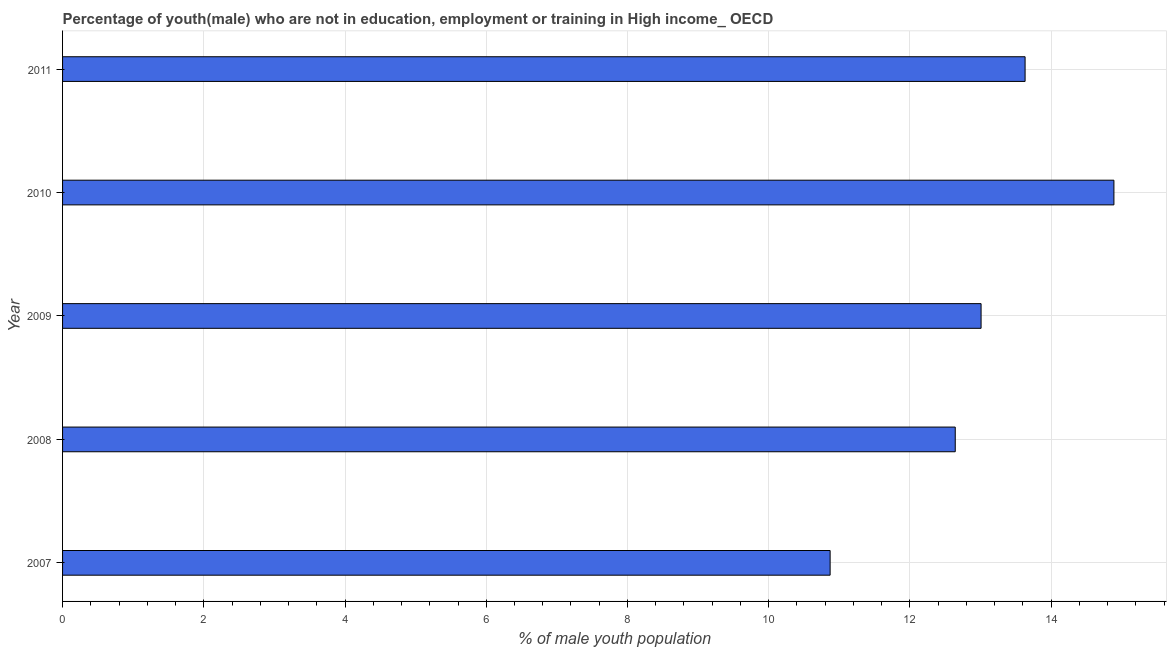Does the graph contain any zero values?
Give a very brief answer. No. What is the title of the graph?
Offer a terse response. Percentage of youth(male) who are not in education, employment or training in High income_ OECD. What is the label or title of the X-axis?
Keep it short and to the point. % of male youth population. What is the label or title of the Y-axis?
Your answer should be very brief. Year. What is the unemployed male youth population in 2008?
Make the answer very short. 12.64. Across all years, what is the maximum unemployed male youth population?
Your answer should be compact. 14.89. Across all years, what is the minimum unemployed male youth population?
Provide a succinct answer. 10.87. In which year was the unemployed male youth population minimum?
Provide a succinct answer. 2007. What is the sum of the unemployed male youth population?
Your answer should be very brief. 65.04. What is the difference between the unemployed male youth population in 2009 and 2011?
Offer a terse response. -0.62. What is the average unemployed male youth population per year?
Keep it short and to the point. 13.01. What is the median unemployed male youth population?
Offer a very short reply. 13.01. In how many years, is the unemployed male youth population greater than 13.2 %?
Give a very brief answer. 2. Do a majority of the years between 2008 and 2010 (inclusive) have unemployed male youth population greater than 10 %?
Offer a terse response. Yes. What is the ratio of the unemployed male youth population in 2007 to that in 2008?
Provide a short and direct response. 0.86. What is the difference between the highest and the second highest unemployed male youth population?
Your answer should be very brief. 1.26. What is the difference between the highest and the lowest unemployed male youth population?
Make the answer very short. 4.02. In how many years, is the unemployed male youth population greater than the average unemployed male youth population taken over all years?
Offer a very short reply. 2. Are all the bars in the graph horizontal?
Your answer should be very brief. Yes. What is the difference between two consecutive major ticks on the X-axis?
Your answer should be compact. 2. What is the % of male youth population of 2007?
Your response must be concise. 10.87. What is the % of male youth population of 2008?
Ensure brevity in your answer.  12.64. What is the % of male youth population in 2009?
Offer a very short reply. 13.01. What is the % of male youth population of 2010?
Give a very brief answer. 14.89. What is the % of male youth population in 2011?
Give a very brief answer. 13.63. What is the difference between the % of male youth population in 2007 and 2008?
Provide a succinct answer. -1.77. What is the difference between the % of male youth population in 2007 and 2009?
Provide a short and direct response. -2.14. What is the difference between the % of male youth population in 2007 and 2010?
Give a very brief answer. -4.02. What is the difference between the % of male youth population in 2007 and 2011?
Ensure brevity in your answer.  -2.76. What is the difference between the % of male youth population in 2008 and 2009?
Your response must be concise. -0.37. What is the difference between the % of male youth population in 2008 and 2010?
Your answer should be very brief. -2.25. What is the difference between the % of male youth population in 2008 and 2011?
Provide a succinct answer. -0.99. What is the difference between the % of male youth population in 2009 and 2010?
Keep it short and to the point. -1.88. What is the difference between the % of male youth population in 2009 and 2011?
Offer a very short reply. -0.62. What is the difference between the % of male youth population in 2010 and 2011?
Make the answer very short. 1.26. What is the ratio of the % of male youth population in 2007 to that in 2008?
Ensure brevity in your answer.  0.86. What is the ratio of the % of male youth population in 2007 to that in 2009?
Your answer should be very brief. 0.84. What is the ratio of the % of male youth population in 2007 to that in 2010?
Provide a short and direct response. 0.73. What is the ratio of the % of male youth population in 2007 to that in 2011?
Provide a succinct answer. 0.8. What is the ratio of the % of male youth population in 2008 to that in 2009?
Your answer should be compact. 0.97. What is the ratio of the % of male youth population in 2008 to that in 2010?
Offer a terse response. 0.85. What is the ratio of the % of male youth population in 2008 to that in 2011?
Ensure brevity in your answer.  0.93. What is the ratio of the % of male youth population in 2009 to that in 2010?
Provide a succinct answer. 0.87. What is the ratio of the % of male youth population in 2009 to that in 2011?
Give a very brief answer. 0.95. What is the ratio of the % of male youth population in 2010 to that in 2011?
Keep it short and to the point. 1.09. 